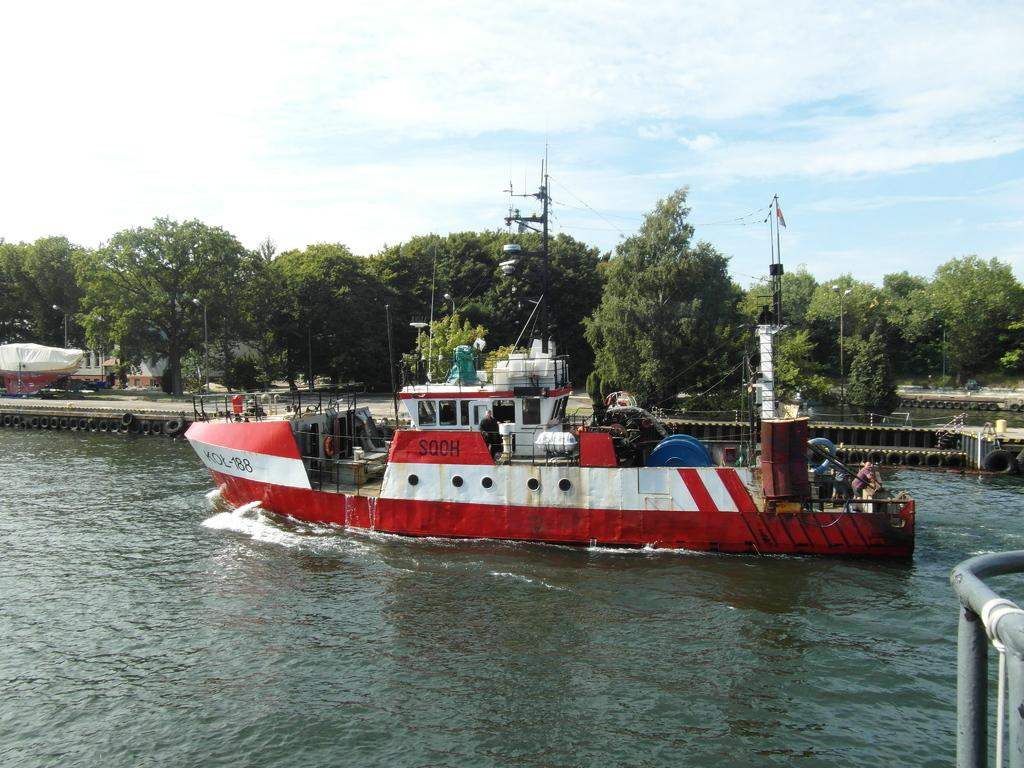What can be seen in the sky in the image? The sky is visible in the image. What type of vegetation is present in the image? There are trees in the image. What objects are related to transportation in the image? There are tyres in the image. What is located in the river in the image? There is a boat in the river in the image. What part of the image is not fully visible? There is an object truncated towards the right side of the image. What type of stove can be seen in the image? There is no stove present in the image. What knowledge can be gained from the minute details in the image? The image does not contain any minute details that would provide additional knowledge. 